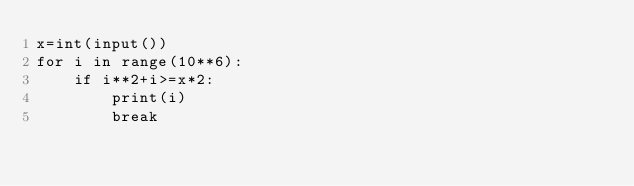<code> <loc_0><loc_0><loc_500><loc_500><_Python_>x=int(input())
for i in range(10**6):
    if i**2+i>=x*2:
        print(i)
        break</code> 